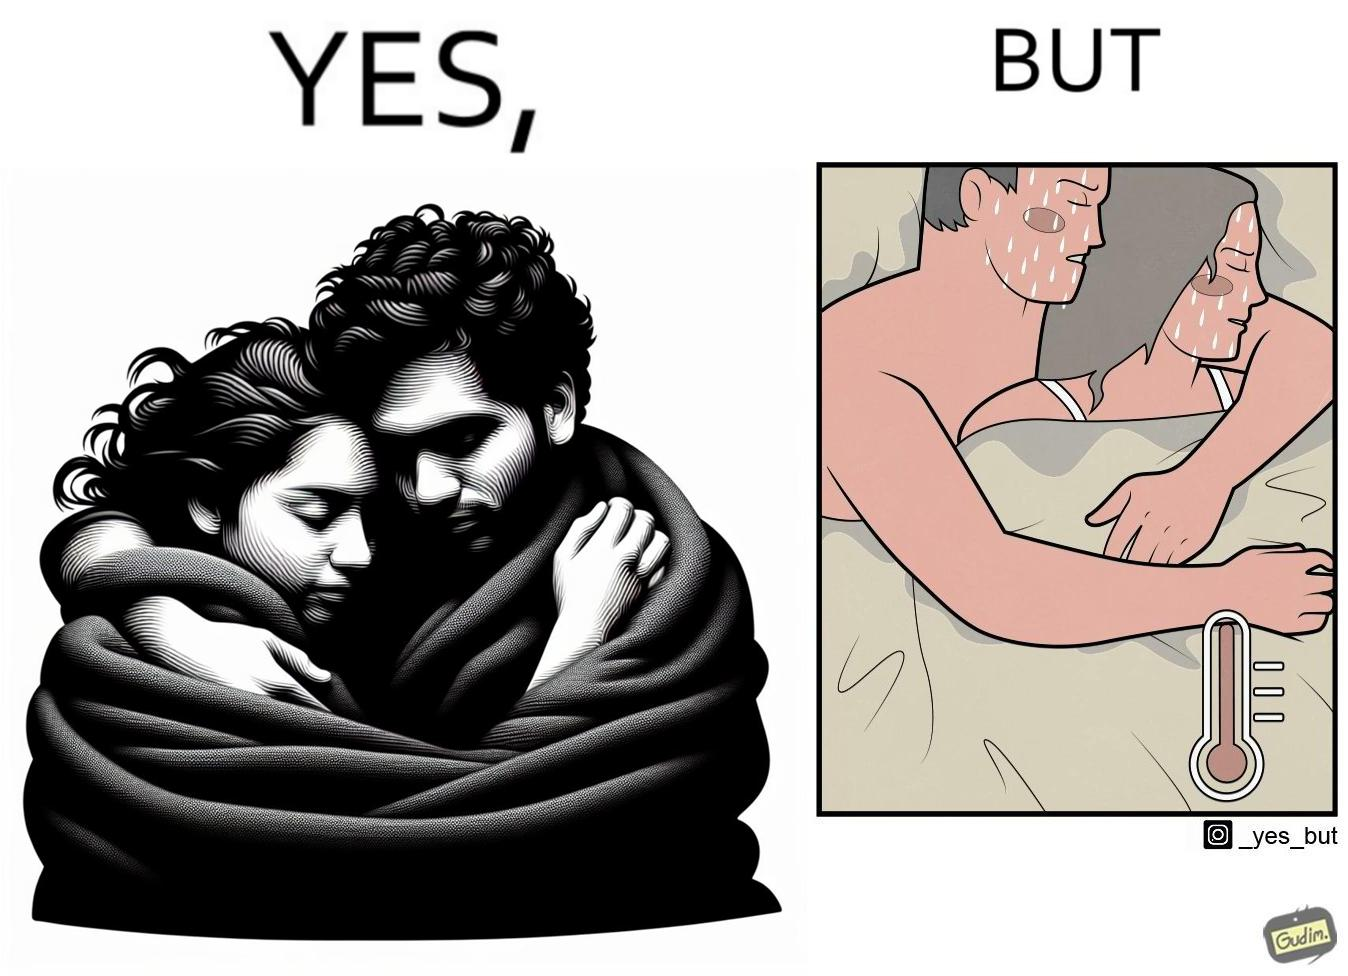Would you classify this image as satirical? Yes, this image is satirical. 